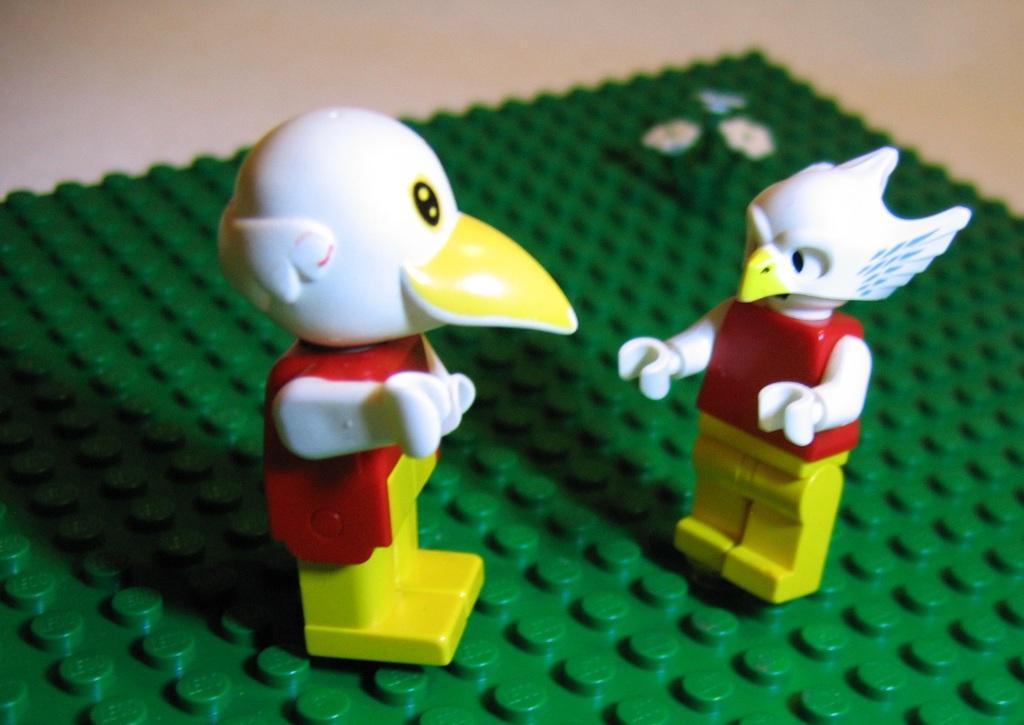Please provide a concise description of this image. In this image, we can see two toys on the green color object. 